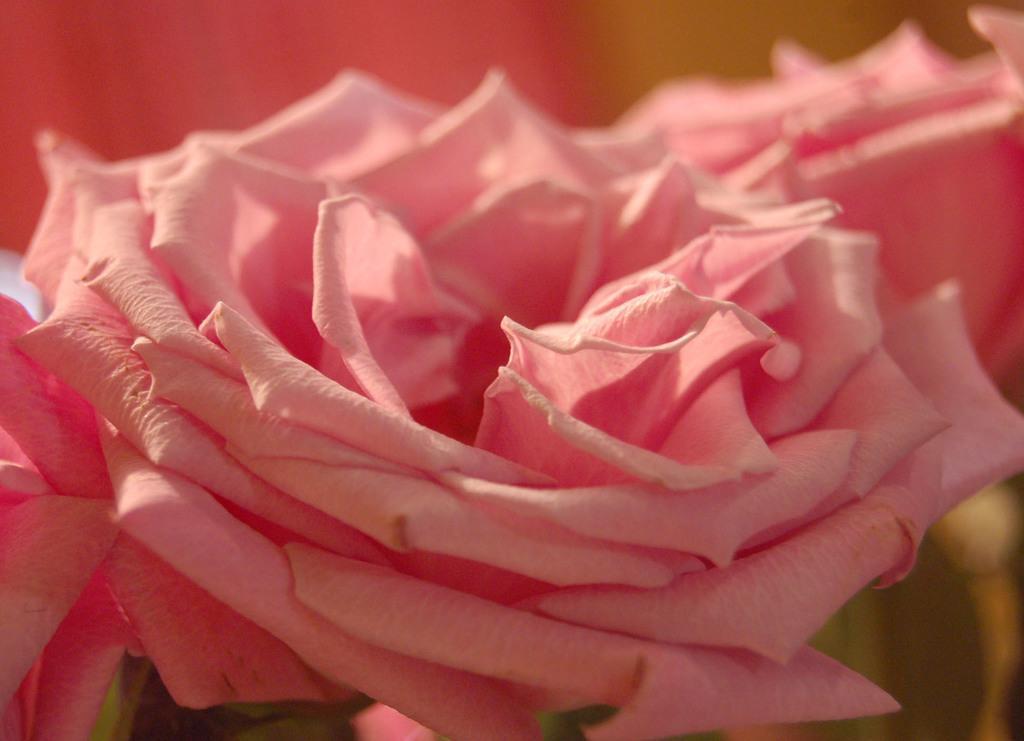In one or two sentences, can you explain what this image depicts? In the picture we can see a flower which is in pink color. 